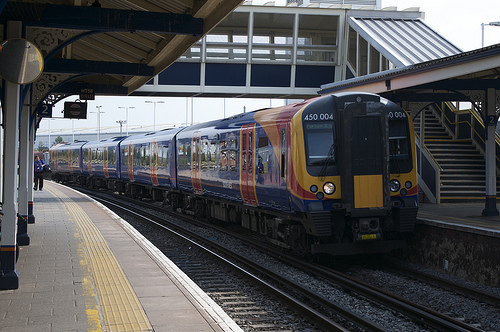Please provide the bounding box coordinate of the region this sentence describes: a loading platform near a train. The loading platform near a train is encompassed within the coordinates [0.0, 0.52, 0.49, 0.83]. This platform is utilized for the boarding and disembarking of passengers, playing a crucial role in train station operations. 